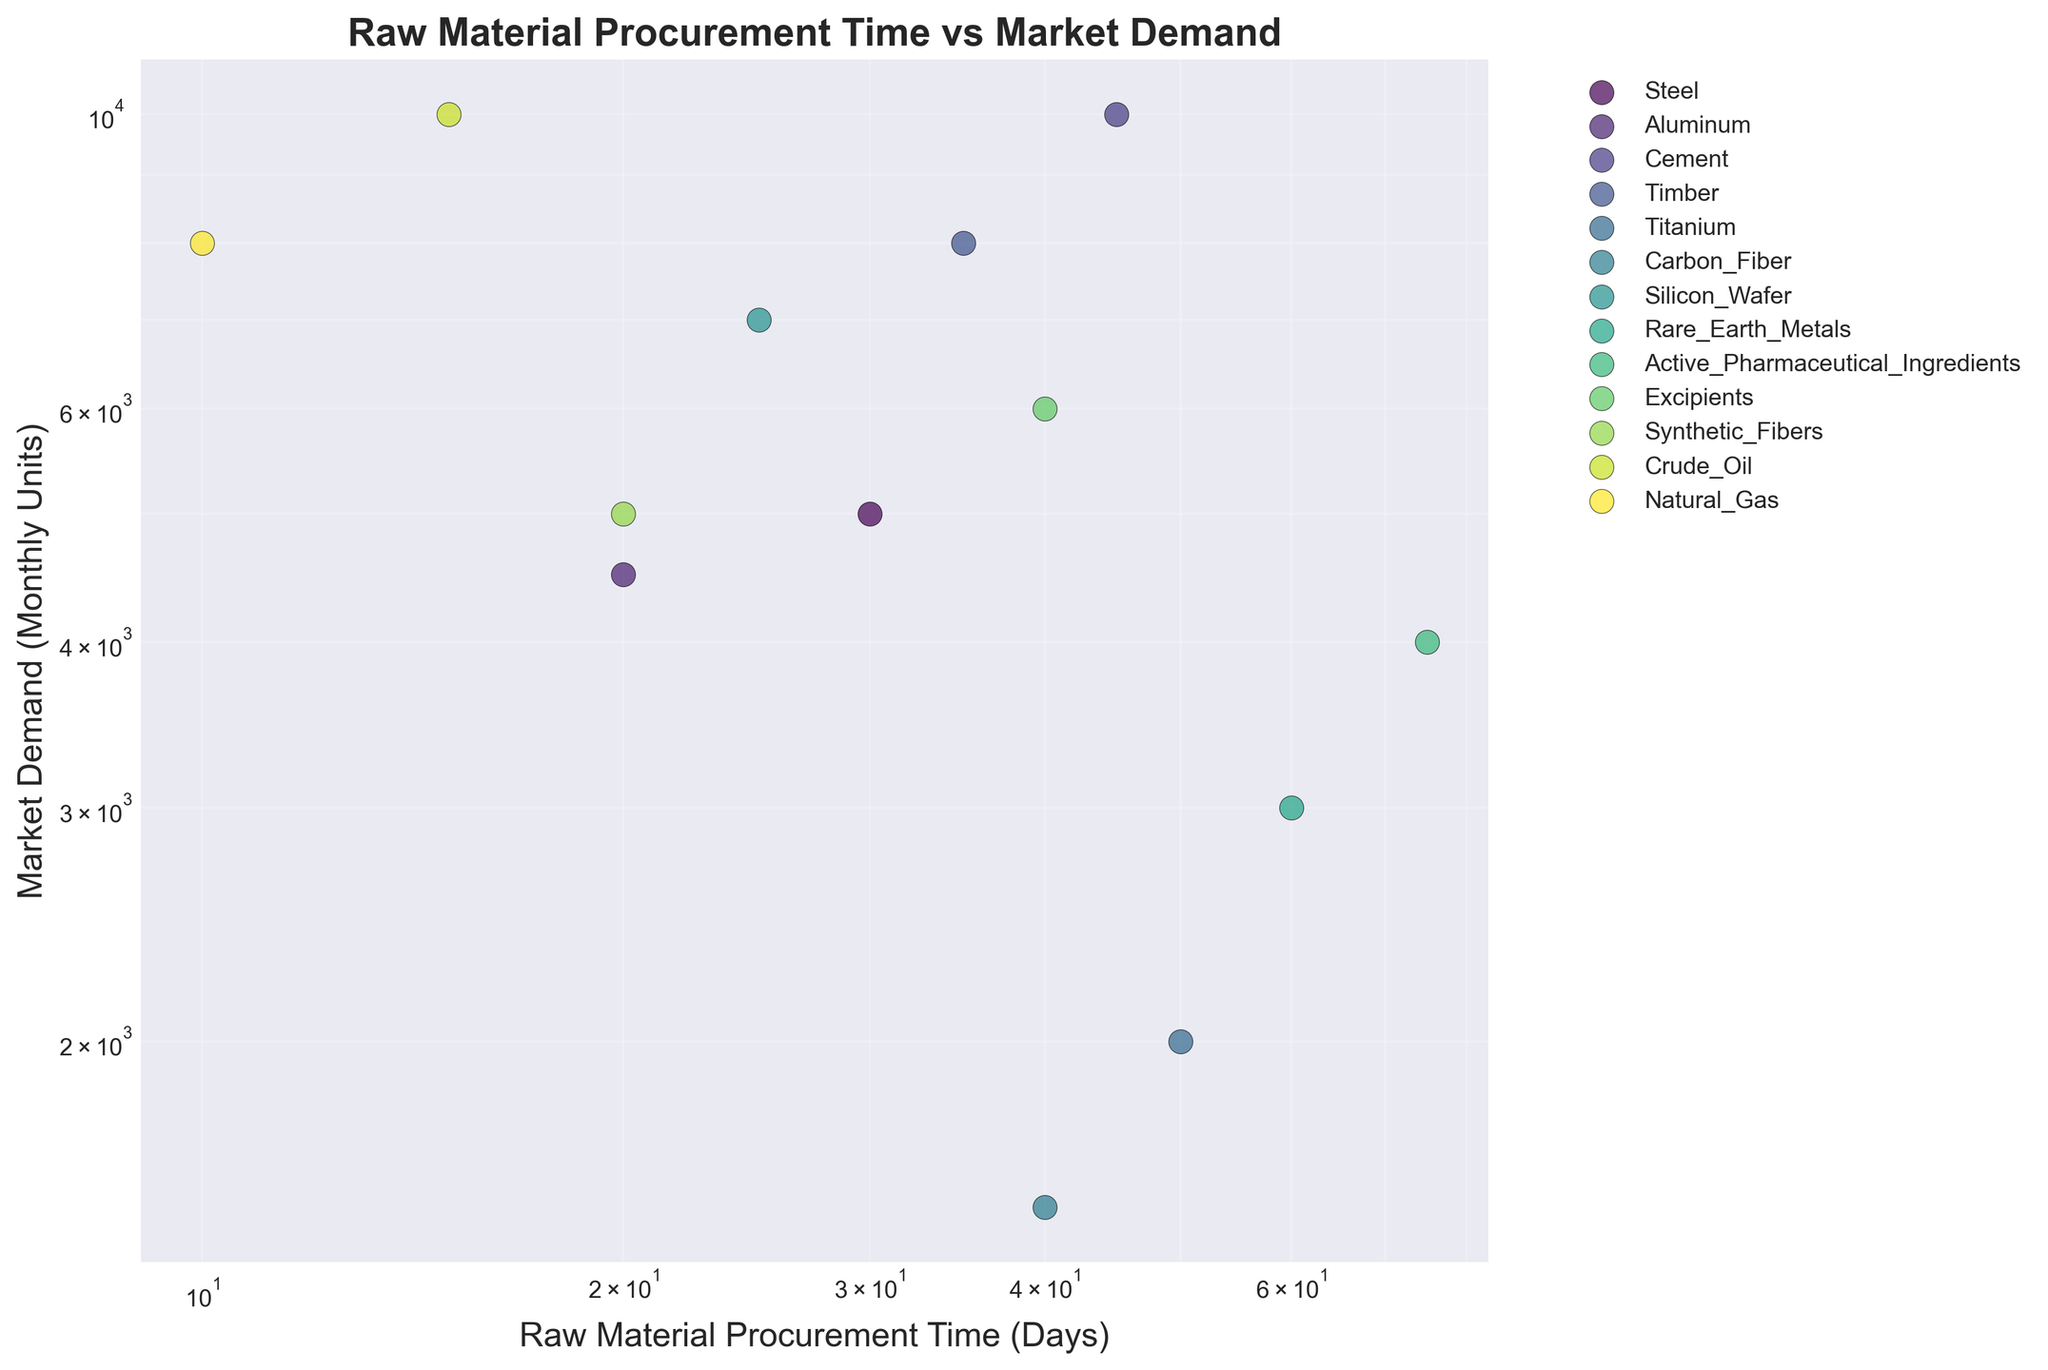What is the title of the figure? The title of the figure can be found at the top of the plot. It states the main subject and context of the scatter plot.
Answer: Raw Material Procurement Time vs Market Demand How many different industrial sectors are represented in the plot? Each unique color represents a different industrial sector. We count the number of unique colors in the legend.
Answer: 7 Which industrial sector has the data point with the shortest procurement time? Look for the data point on the x-axis with the smallest procurement time. The sector can be identified from the legend based on the color of the point.
Answer: Energy What are the axes in this scatter plot? The labels of the axes are located along the x and y-axis respectively. The x-axis denotes 'Raw Material Procurement Time (Days)' and the y-axis denotes 'Market Demand (Monthly Units)'. Both axes use a logarithmic scale.
Answer: Raw Material Procurement Time (Days) and Market Demand (Monthly Units) Which data point has the highest market demand? Find the highest point on the y-axis. Use the legend to identify the color associated with this point.
Answer: Construction - Cement Which industrial sector's data points are clustered closest together? Look for a group of points that are physically near each other on the plot. The color of the points will indicate the sector.
Answer: Electronics Which sector has the widest range in procurement times? Calculate the difference between the maximum and minimum procurement times for each sector by observing the spread of points along the x-axis. The sector with the widest spread has the largest range.
Answer: Pharmaceuticals Compare the market demand for automotive sector materials. Which material has a higher demand? Locate the points for 'Automotive' and compare their positions on the y-axis. The higher point has the higher demand.
Answer: Steel What is the proportion of procurement time for crude oil to natural gas in the energy sector? Identify the procurement times of crude oil (15 days) and natural gas (10 days) by their y-position. Calculate the ratio 15/10.
Answer: 1.5 What is the approximate market demand difference between titanium and carbon fiber in the aerospace sector? Locate the points for 'Aerospace' and read their y-values. Subtract the market demand of carbon fiber from that of titanium.
Answer: 500 